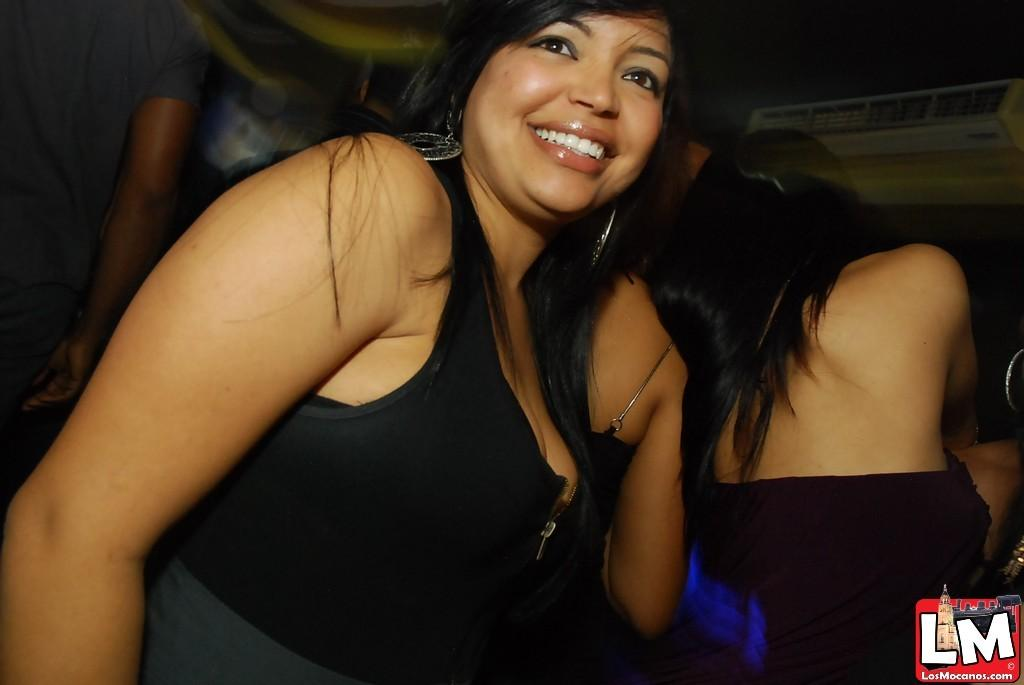<image>
Render a clear and concise summary of the photo. Two woman are wearing black and have been documented by LM. 